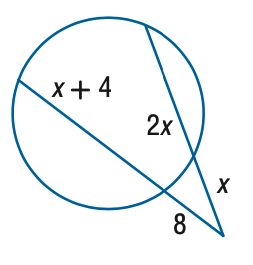Answer the mathemtical geometry problem and directly provide the correct option letter.
Question: Find the variable of x to the nearest tenth.
Choices: A: 6.1 B: 6.6 C: 7.1 D: 7.6 C 